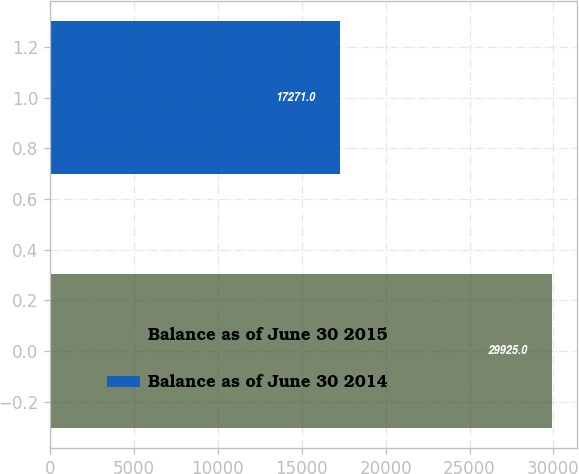Convert chart. <chart><loc_0><loc_0><loc_500><loc_500><bar_chart><fcel>Balance as of June 30 2015<fcel>Balance as of June 30 2014<nl><fcel>29925<fcel>17271<nl></chart> 